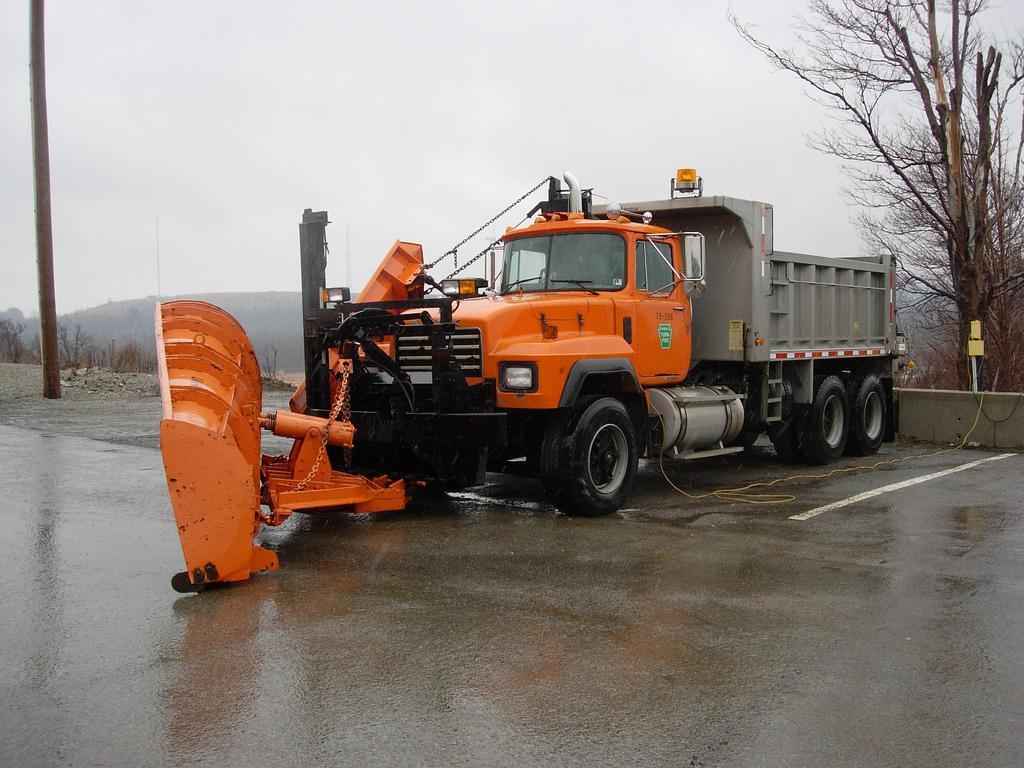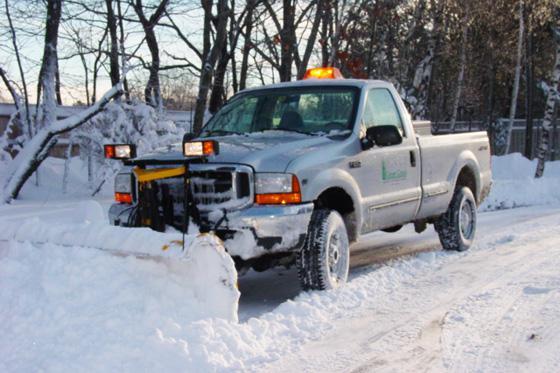The first image is the image on the left, the second image is the image on the right. Considering the images on both sides, is "An image features a truck with an orange plow and orange cab on a non-snowy surface." valid? Answer yes or no. Yes. The first image is the image on the left, the second image is the image on the right. Given the left and right images, does the statement "In one image, a white truck with snow blade is in a snowy area near trees, while a second image shows an orange truck with an angled orange blade." hold true? Answer yes or no. Yes. 